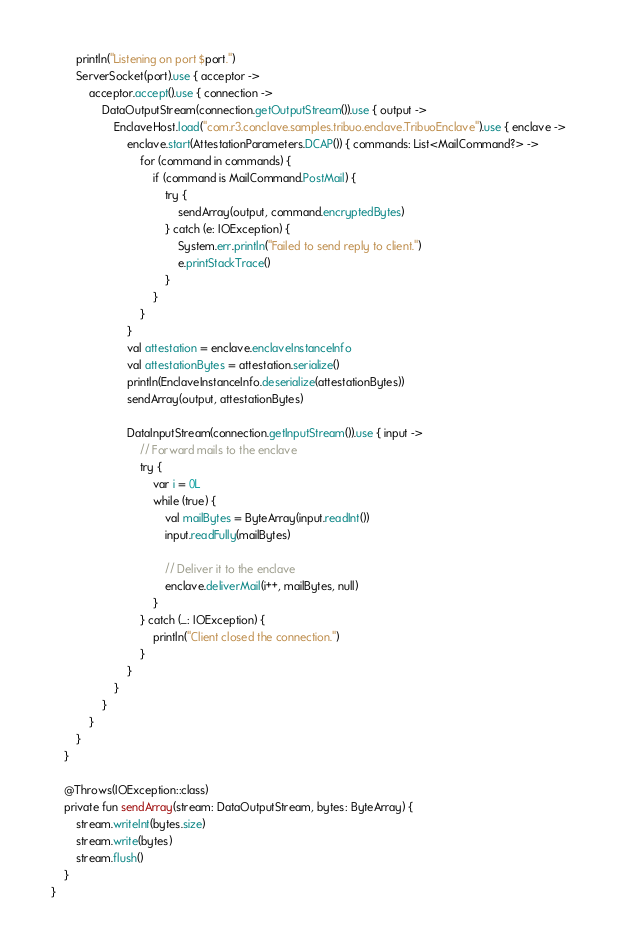<code> <loc_0><loc_0><loc_500><loc_500><_Kotlin_>        println("Listening on port $port.")
        ServerSocket(port).use { acceptor ->
            acceptor.accept().use { connection ->
                DataOutputStream(connection.getOutputStream()).use { output ->
                    EnclaveHost.load("com.r3.conclave.samples.tribuo.enclave.TribuoEnclave").use { enclave ->
                        enclave.start(AttestationParameters.DCAP()) { commands: List<MailCommand?> ->
                            for (command in commands) {
                                if (command is MailCommand.PostMail) {
                                    try {
                                        sendArray(output, command.encryptedBytes)
                                    } catch (e: IOException) {
                                        System.err.println("Failed to send reply to client.")
                                        e.printStackTrace()
                                    }
                                }
                            }
                        }
                        val attestation = enclave.enclaveInstanceInfo
                        val attestationBytes = attestation.serialize()
                        println(EnclaveInstanceInfo.deserialize(attestationBytes))
                        sendArray(output, attestationBytes)

                        DataInputStream(connection.getInputStream()).use { input ->
                            // Forward mails to the enclave
                            try {
                                var i = 0L
                                while (true) {
                                    val mailBytes = ByteArray(input.readInt())
                                    input.readFully(mailBytes)

                                    // Deliver it to the enclave
                                    enclave.deliverMail(i++, mailBytes, null)
                                }
                            } catch (_: IOException) {
                                println("Client closed the connection.")
                            }
                        }
                    }
                }
            }
        }
    }

    @Throws(IOException::class)
    private fun sendArray(stream: DataOutputStream, bytes: ByteArray) {
        stream.writeInt(bytes.size)
        stream.write(bytes)
        stream.flush()
    }
}</code> 